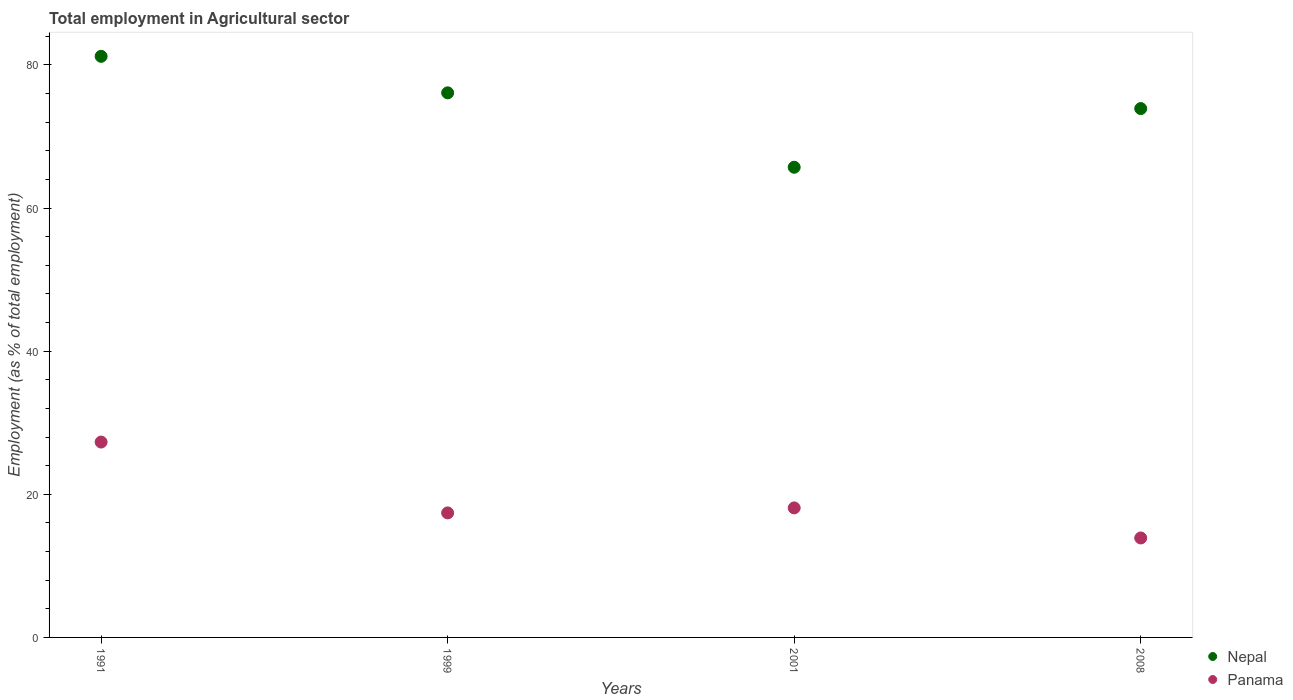How many different coloured dotlines are there?
Keep it short and to the point. 2. What is the employment in agricultural sector in Nepal in 2001?
Provide a short and direct response. 65.7. Across all years, what is the maximum employment in agricultural sector in Panama?
Your response must be concise. 27.3. Across all years, what is the minimum employment in agricultural sector in Nepal?
Keep it short and to the point. 65.7. In which year was the employment in agricultural sector in Panama minimum?
Offer a very short reply. 2008. What is the total employment in agricultural sector in Nepal in the graph?
Offer a very short reply. 296.9. What is the difference between the employment in agricultural sector in Panama in 1991 and that in 1999?
Your answer should be compact. 9.9. What is the difference between the employment in agricultural sector in Panama in 1991 and the employment in agricultural sector in Nepal in 1999?
Your answer should be compact. -48.8. What is the average employment in agricultural sector in Nepal per year?
Offer a terse response. 74.22. In the year 2001, what is the difference between the employment in agricultural sector in Panama and employment in agricultural sector in Nepal?
Offer a very short reply. -47.6. In how many years, is the employment in agricultural sector in Nepal greater than 80 %?
Provide a succinct answer. 1. What is the ratio of the employment in agricultural sector in Panama in 1991 to that in 2001?
Give a very brief answer. 1.51. What is the difference between the highest and the second highest employment in agricultural sector in Panama?
Your answer should be compact. 9.2. What is the difference between the highest and the lowest employment in agricultural sector in Panama?
Your response must be concise. 13.4. In how many years, is the employment in agricultural sector in Nepal greater than the average employment in agricultural sector in Nepal taken over all years?
Give a very brief answer. 2. Does the employment in agricultural sector in Nepal monotonically increase over the years?
Provide a succinct answer. No. What is the difference between two consecutive major ticks on the Y-axis?
Offer a very short reply. 20. Are the values on the major ticks of Y-axis written in scientific E-notation?
Your response must be concise. No. How are the legend labels stacked?
Your answer should be very brief. Vertical. What is the title of the graph?
Provide a short and direct response. Total employment in Agricultural sector. What is the label or title of the X-axis?
Keep it short and to the point. Years. What is the label or title of the Y-axis?
Give a very brief answer. Employment (as % of total employment). What is the Employment (as % of total employment) of Nepal in 1991?
Your answer should be very brief. 81.2. What is the Employment (as % of total employment) of Panama in 1991?
Keep it short and to the point. 27.3. What is the Employment (as % of total employment) in Nepal in 1999?
Give a very brief answer. 76.1. What is the Employment (as % of total employment) in Panama in 1999?
Offer a terse response. 17.4. What is the Employment (as % of total employment) of Nepal in 2001?
Your answer should be very brief. 65.7. What is the Employment (as % of total employment) in Panama in 2001?
Ensure brevity in your answer.  18.1. What is the Employment (as % of total employment) of Nepal in 2008?
Your response must be concise. 73.9. What is the Employment (as % of total employment) of Panama in 2008?
Provide a succinct answer. 13.9. Across all years, what is the maximum Employment (as % of total employment) in Nepal?
Ensure brevity in your answer.  81.2. Across all years, what is the maximum Employment (as % of total employment) of Panama?
Your response must be concise. 27.3. Across all years, what is the minimum Employment (as % of total employment) of Nepal?
Make the answer very short. 65.7. Across all years, what is the minimum Employment (as % of total employment) in Panama?
Make the answer very short. 13.9. What is the total Employment (as % of total employment) of Nepal in the graph?
Ensure brevity in your answer.  296.9. What is the total Employment (as % of total employment) in Panama in the graph?
Provide a succinct answer. 76.7. What is the difference between the Employment (as % of total employment) in Nepal in 1991 and that in 1999?
Ensure brevity in your answer.  5.1. What is the difference between the Employment (as % of total employment) of Panama in 1991 and that in 2008?
Provide a succinct answer. 13.4. What is the difference between the Employment (as % of total employment) of Nepal in 1999 and that in 2001?
Give a very brief answer. 10.4. What is the difference between the Employment (as % of total employment) of Nepal in 1999 and that in 2008?
Your response must be concise. 2.2. What is the difference between the Employment (as % of total employment) in Panama in 1999 and that in 2008?
Offer a very short reply. 3.5. What is the difference between the Employment (as % of total employment) in Nepal in 2001 and that in 2008?
Offer a terse response. -8.2. What is the difference between the Employment (as % of total employment) of Nepal in 1991 and the Employment (as % of total employment) of Panama in 1999?
Provide a short and direct response. 63.8. What is the difference between the Employment (as % of total employment) of Nepal in 1991 and the Employment (as % of total employment) of Panama in 2001?
Your answer should be very brief. 63.1. What is the difference between the Employment (as % of total employment) of Nepal in 1991 and the Employment (as % of total employment) of Panama in 2008?
Provide a short and direct response. 67.3. What is the difference between the Employment (as % of total employment) of Nepal in 1999 and the Employment (as % of total employment) of Panama in 2001?
Give a very brief answer. 58. What is the difference between the Employment (as % of total employment) in Nepal in 1999 and the Employment (as % of total employment) in Panama in 2008?
Keep it short and to the point. 62.2. What is the difference between the Employment (as % of total employment) of Nepal in 2001 and the Employment (as % of total employment) of Panama in 2008?
Offer a very short reply. 51.8. What is the average Employment (as % of total employment) in Nepal per year?
Ensure brevity in your answer.  74.22. What is the average Employment (as % of total employment) in Panama per year?
Provide a short and direct response. 19.18. In the year 1991, what is the difference between the Employment (as % of total employment) in Nepal and Employment (as % of total employment) in Panama?
Provide a succinct answer. 53.9. In the year 1999, what is the difference between the Employment (as % of total employment) in Nepal and Employment (as % of total employment) in Panama?
Your answer should be very brief. 58.7. In the year 2001, what is the difference between the Employment (as % of total employment) in Nepal and Employment (as % of total employment) in Panama?
Provide a succinct answer. 47.6. In the year 2008, what is the difference between the Employment (as % of total employment) of Nepal and Employment (as % of total employment) of Panama?
Your response must be concise. 60. What is the ratio of the Employment (as % of total employment) in Nepal in 1991 to that in 1999?
Keep it short and to the point. 1.07. What is the ratio of the Employment (as % of total employment) in Panama in 1991 to that in 1999?
Keep it short and to the point. 1.57. What is the ratio of the Employment (as % of total employment) in Nepal in 1991 to that in 2001?
Provide a succinct answer. 1.24. What is the ratio of the Employment (as % of total employment) of Panama in 1991 to that in 2001?
Offer a very short reply. 1.51. What is the ratio of the Employment (as % of total employment) of Nepal in 1991 to that in 2008?
Give a very brief answer. 1.1. What is the ratio of the Employment (as % of total employment) of Panama in 1991 to that in 2008?
Offer a very short reply. 1.96. What is the ratio of the Employment (as % of total employment) of Nepal in 1999 to that in 2001?
Keep it short and to the point. 1.16. What is the ratio of the Employment (as % of total employment) of Panama in 1999 to that in 2001?
Your answer should be compact. 0.96. What is the ratio of the Employment (as % of total employment) in Nepal in 1999 to that in 2008?
Ensure brevity in your answer.  1.03. What is the ratio of the Employment (as % of total employment) in Panama in 1999 to that in 2008?
Your answer should be compact. 1.25. What is the ratio of the Employment (as % of total employment) of Nepal in 2001 to that in 2008?
Offer a terse response. 0.89. What is the ratio of the Employment (as % of total employment) in Panama in 2001 to that in 2008?
Your answer should be very brief. 1.3. What is the difference between the highest and the second highest Employment (as % of total employment) of Panama?
Provide a succinct answer. 9.2. What is the difference between the highest and the lowest Employment (as % of total employment) of Nepal?
Offer a very short reply. 15.5. 